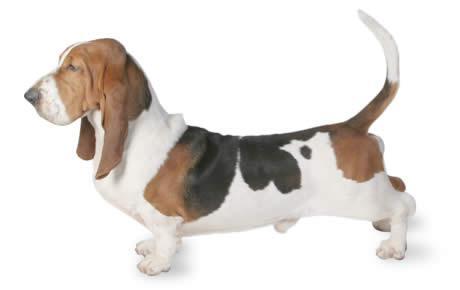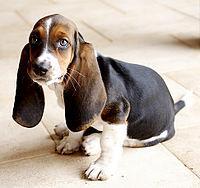The first image is the image on the left, the second image is the image on the right. Evaluate the accuracy of this statement regarding the images: "At least one dog has no visible black in their fur.". Is it true? Answer yes or no. No. 